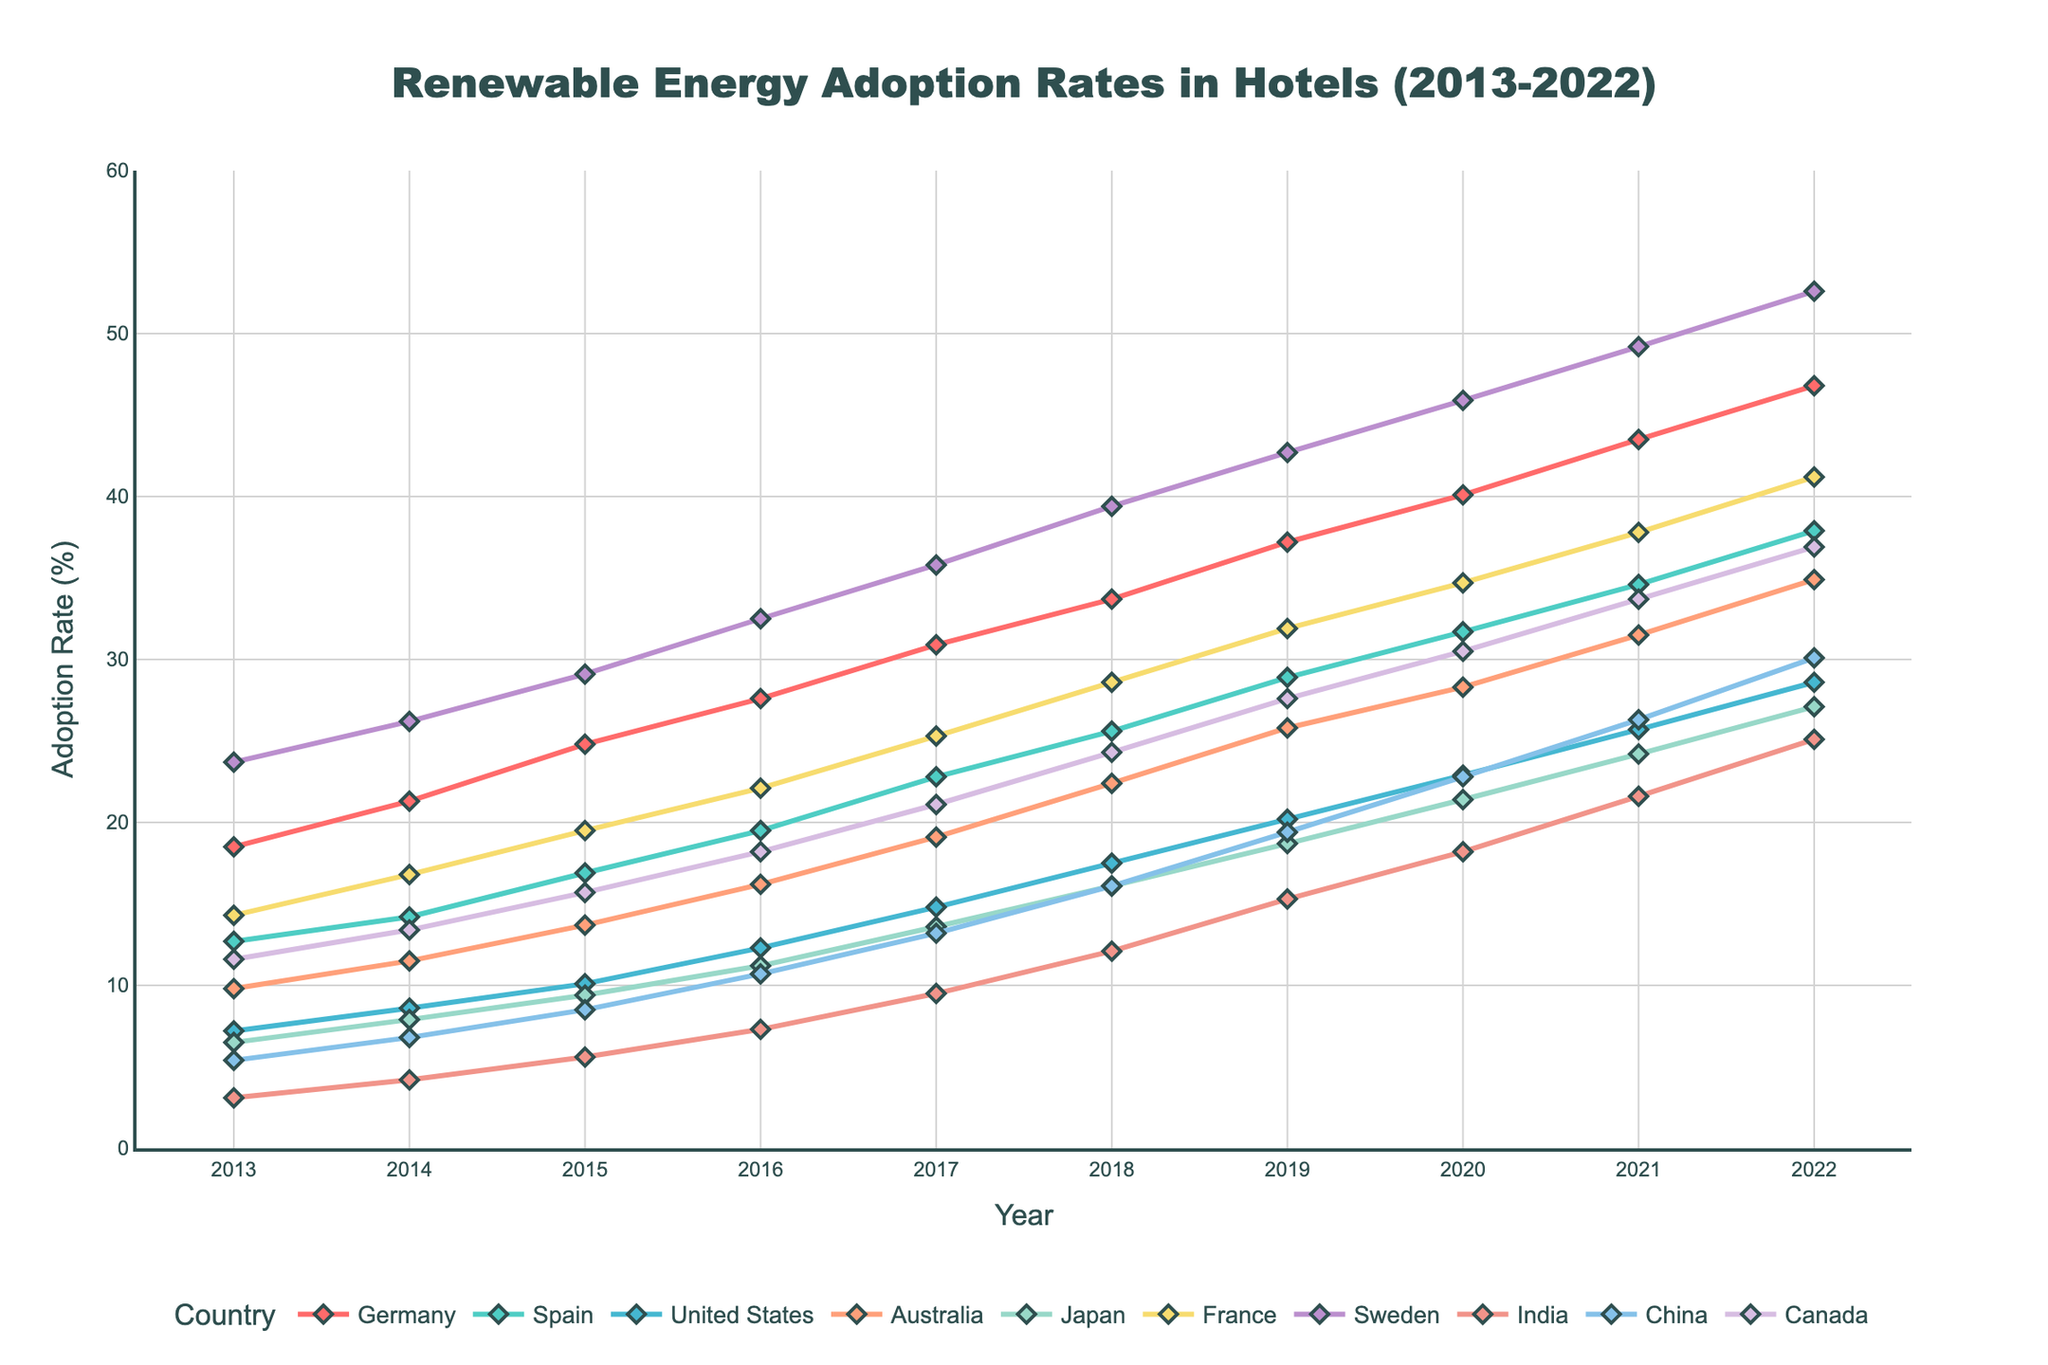What is the adoption rate difference between Sweden and India in 2022? In 2022, Sweden has an adoption rate of 52.6%, and India has an adoption rate of 25.1%. Subtract India's rate from Sweden's rate: 52.6 - 25.1 = 27.5
Answer: 27.5% Which country had the highest adoption rate of renewable energy in hotels in 2020? According to the figure, in 2020, Sweden has the highest adoption rate with 45.9%.
Answer: Sweden What is the average adoption rate of renewable energy in hotels in Canada from 2013 to 2022? Sum the adoption rates of Canada for all years from 2013 to 2022 and then divide by the number of years: (11.6 + 13.4 + 15.7 + 18.2 + 21.1 + 24.3 + 27.6 + 30.5 + 33.7 + 36.9) / 10 = 23.3
Answer: 23.3% Which country showed the largest growth in renewable energy adoption rate between 2013 and 2022? Calculate the growth for each country by subtracting the 2013 rate from the 2022 rate. The country with the largest difference is Sweden with a growth of 52.6 - 23.7 = 28.9
Answer: Sweden Compare the adoption rates of renewable energy in hotels between Germany and France in 2018. Which country had a higher rate? In 2018, Germany had an adoption rate of 33.7%, while France had an adoption rate of 28.6%. Germany had a higher rate.
Answer: Germany What is the adoption rate trend for Japan from 2013 to 2022? The adoption rate in Japan shows a steady upward trend from 6.5% in 2013 to 27.1% in 2022.
Answer: Steady upward trend What is the total adoption rate of renewable energy for hotels in Spain and Australia combined in 2019? Add Spain's adoption rate (28.9%) and Australia's adoption rate (25.8%) for 2019: 28.9 + 25.8 = 54.7
Answer: 54.7% Which country has consistently shown increasing adoption rates without any decline over the years? By observing the figure, all countries demonstrate consistent incremental increases in adoption rates without any declines.
Answer: All countries In what year did the United States surpass 20% adoption rate in renewable energy for hotels? According to the figure, the United States surpassed 20% adoption rate in 2019 with a rate of 20.2%.
Answer: 2019 